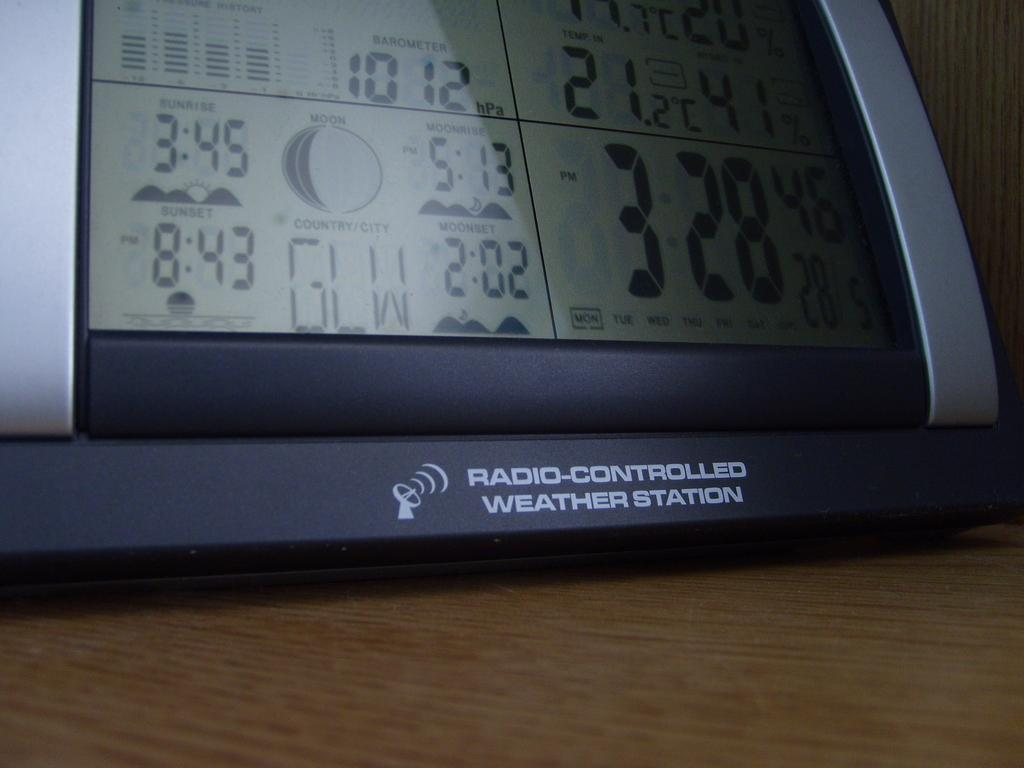What can be seen in the image? There is a device in the image. Where is the device located? The device is placed on a wooden platform. What is visible in the background of the image? There is a wall in the background of the image. Can you see any yams floating in the lake in the image? There is no lake or yams present in the image; it features a device on a wooden platform with a wall in the background. 